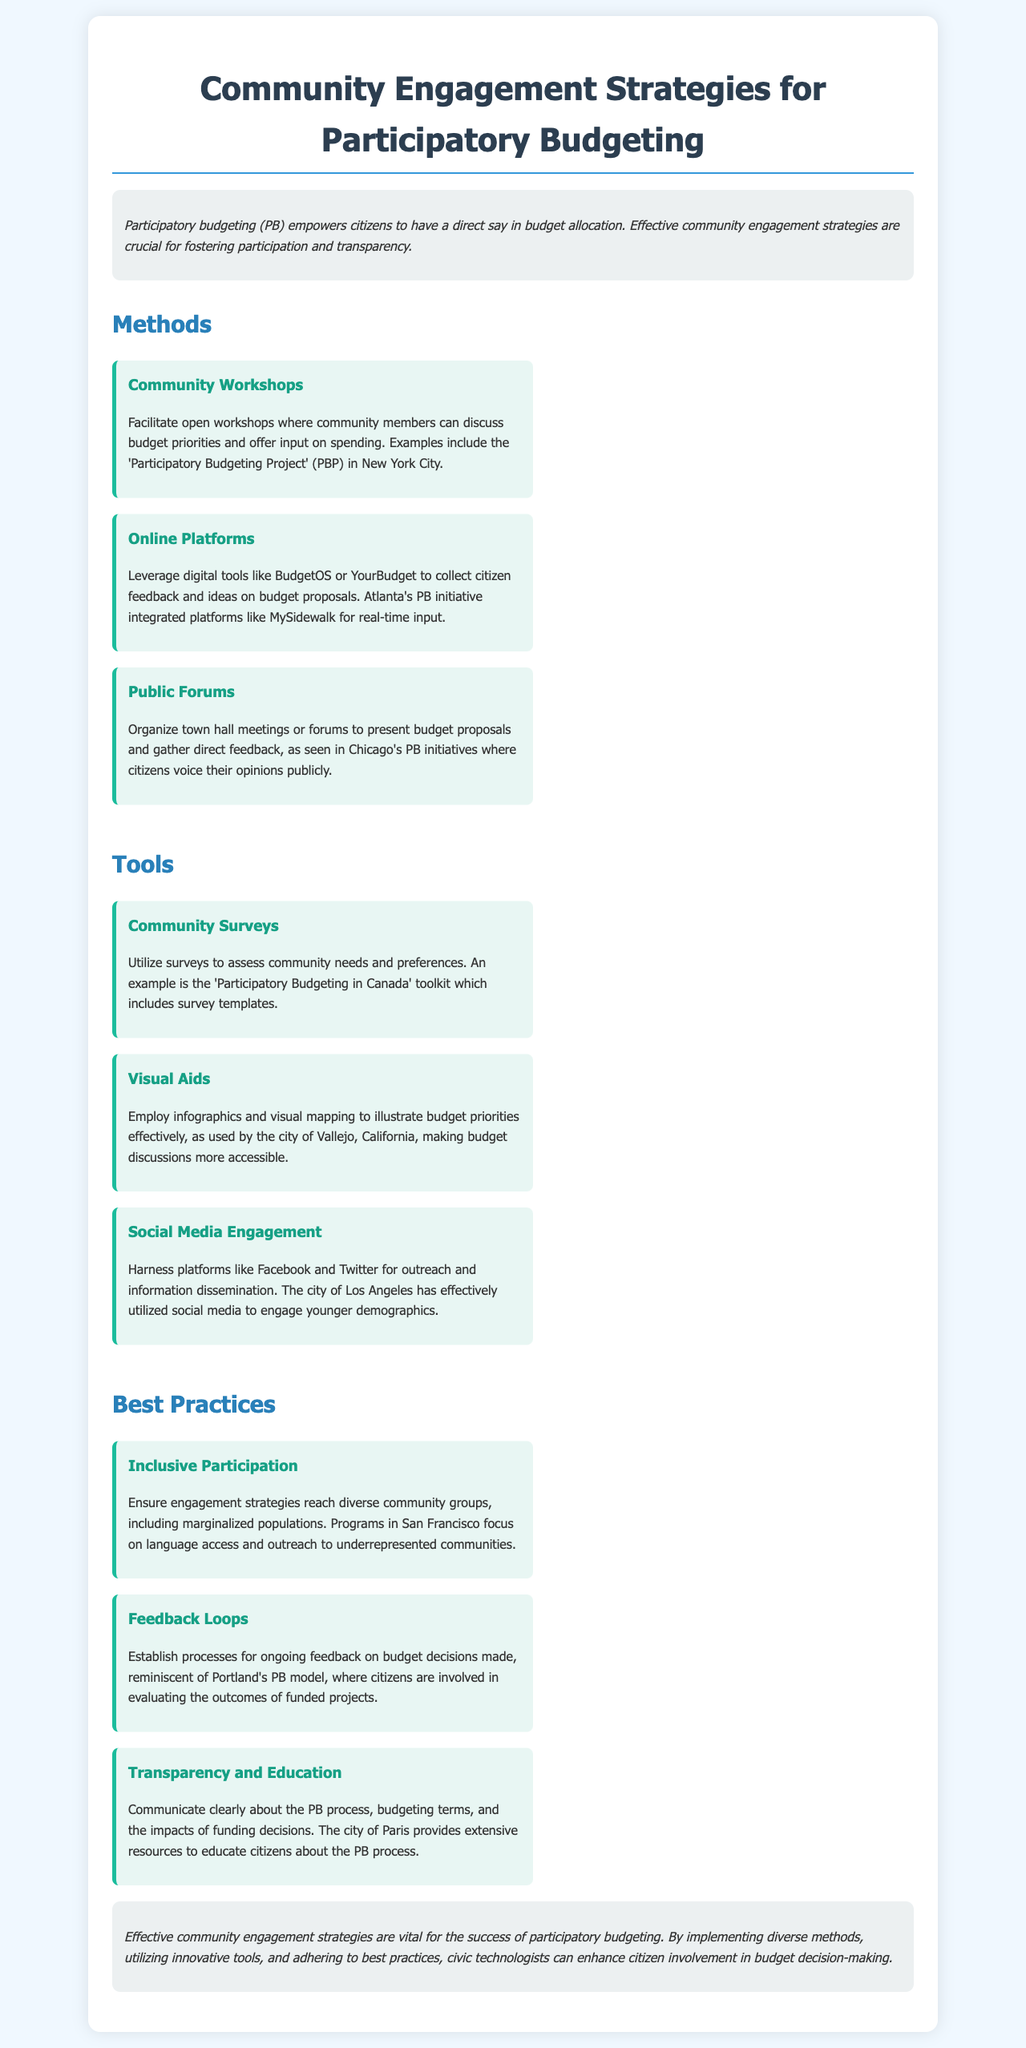what is the title of the brochure? The title is mentioned in the header of the document, clearly stating the purpose of the brochure.
Answer: Community Engagement Strategies for Participatory Budgeting what city implemented the Participatory Budgeting Project mentioned? The document provides a specific example of a city where the PB initiative is ongoing in the context of community workshops.
Answer: New York City which method emphasizes online citizen feedback tools? The document specifies a method that leverages digital tools for citizen engagement in budget proposals.
Answer: Online Platforms what tool is suggested for assessing community needs? The document includes a specific tool that is used to gather information about community preferences.
Answer: Community Surveys which city's PB initiative focused on language access? The document highlights a city's program aimed at improving inclusiveness in participation strategies.
Answer: San Francisco what type of engagement does the document suggest utilizing social media for? The document mentions a specific type of outreach that utilizes social media platforms for engagement.
Answer: Information dissemination how many best practices are discussed in this brochure? The brochure lists a specific number of best practices under the relevant section.
Answer: Three what is one city mentioned that has effectively utilized social media? The document provides an example of a city known for engaging younger demographics through social media.
Answer: Los Angeles what is a key focus of the feedback loops best practice? This best practice in the document discusses a specific aspect of citizen involvement in project evaluation.
Answer: Ongoing feedback 